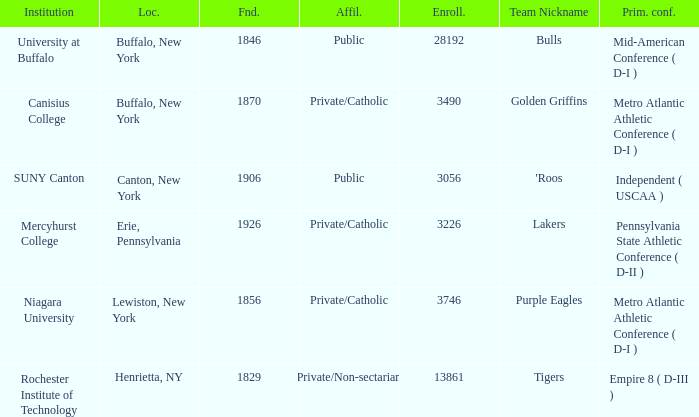What kind of school is Canton, New York? Public. 